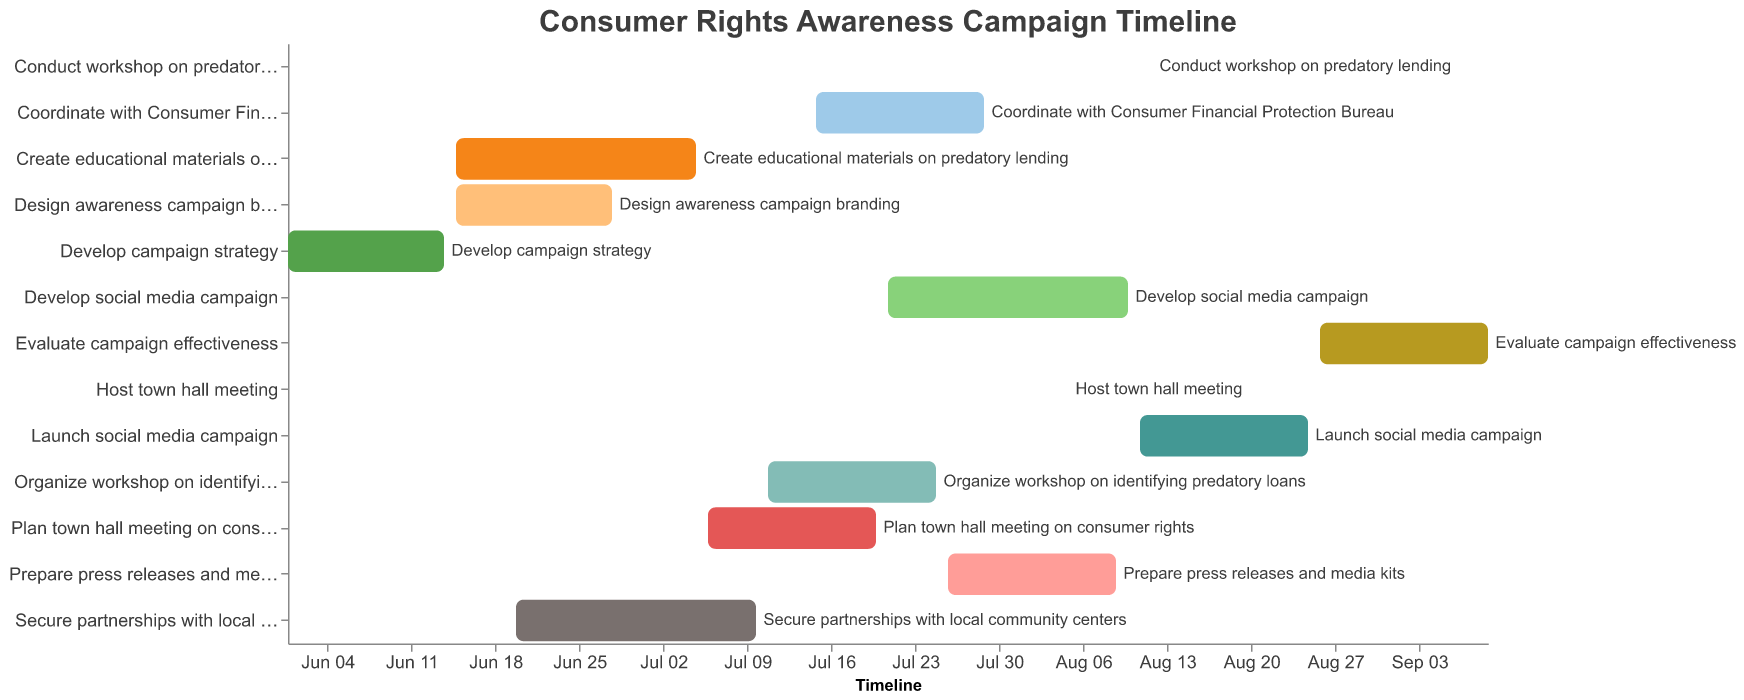What is the title of the chart? The chart has a title at the top. The text reads "Consumer Rights Awareness Campaign Timeline."
Answer: Consumer Rights Awareness Campaign Timeline How many tasks in total are displayed on the Gantt Chart? By counting the bars representing each task, we can determine the total number of tasks.
Answer: 13 Which task has the shortest duration, and what is that duration? By checking the lengths of the bars and the tooltips, we can identify that "Host town hall meeting" and "Conduct workshop on predatory lending" both have the shortest duration of just 1 day each.
Answer: Host town hall meeting and Conduct workshop on predatory lending, 1 day During which date range is the "Develop campaign strategy" task scheduled? The bar for "Develop campaign strategy" starts at June 1, 2023, and ends at June 14, 2023, as indicated by the tooltip.
Answer: June 1, 2023 to June 14, 2023 Which task starts immediately after the "Develop campaign strategy" task ends? By observing the Gantt Chart, "Create educational materials on predatory lending" starts right after "Develop campaign strategy" ends on June 14, 2023.
Answer: Create educational materials on predatory lending How many tasks are ongoing on July 10, 2023? By looking at the date of July 10, 2023 on the x-axis and checking which tasks overlap this date, we can count the bars crossing this point.
Answer: 3 Which task ends on August 9, 2023? By moving along the x-axis to August 9, 2023 and checking the end of the bars, we can see "Prepare press releases and media kits" ends on this date.
Answer: Prepare press releases and media kits Are there any tasks that have the same start date? If so, which ones? By checking the start dates, we find that "Create educational materials on predatory lending" and "Design awareness campaign branding" both start on June 15, 2023.
Answer: Create educational materials on predatory lending and Design awareness campaign branding Which tasks span across the month of July 2023? By looking at tasks that start before July 1 and end after July 31, we can see "Create educational materials on predatory lending," "Secure partnerships with local community centers," "Plan town hall meeting on consumer rights," "Organize workshop on identifying predatory loans," and "Coordinate with Consumer Financial Protection Bureau" span across the month of July 2023.
Answer: Create educational materials on predatory lending, Secure partnerships with local community centers, Plan town hall meeting on consumer rights, Organize workshop on identifying predatory loans, Coordinate with Consumer Financial Protection Bureau What is the combined duration of all tasks planned for August 2023? By summing the durations of tasks that have August dates, we get:
"Develop social media campaign" (10 days in August),
"Prepare press releases and media kits" (9 days in August),
"Host town hall meeting" (1 day in August),
"Launch social media campaign" (15 days in August),
"Conduct workshop on predatory lending" (1 day in August), and
"Evaluate campaign effectiveness" (6 days in August)
10 + 9 + 1 + 15 + 1 + 6 = 42 days
Answer: 42 days 